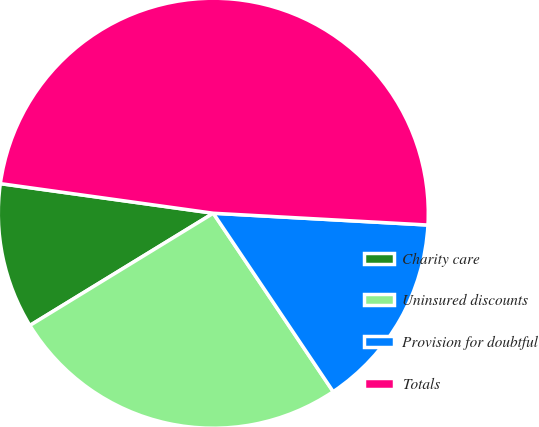Convert chart. <chart><loc_0><loc_0><loc_500><loc_500><pie_chart><fcel>Charity care<fcel>Uninsured discounts<fcel>Provision for doubtful<fcel>Totals<nl><fcel>10.94%<fcel>25.68%<fcel>14.71%<fcel>48.68%<nl></chart> 